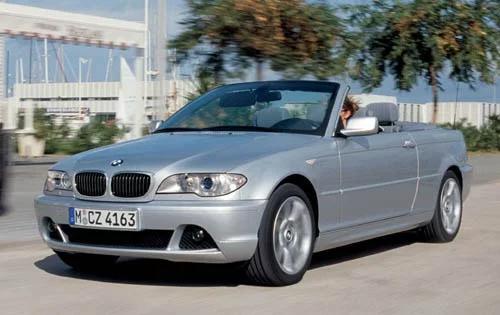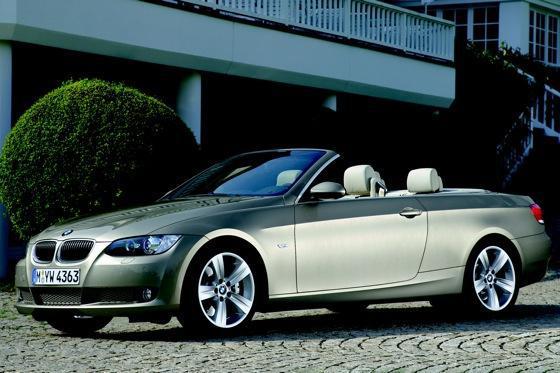The first image is the image on the left, the second image is the image on the right. Given the left and right images, does the statement "An image shows a forward-facing royal blue convertible with some type of wall behind it." hold true? Answer yes or no. No. The first image is the image on the left, the second image is the image on the right. Examine the images to the left and right. Is the description "AN image contains a blue convertible sports car." accurate? Answer yes or no. No. 